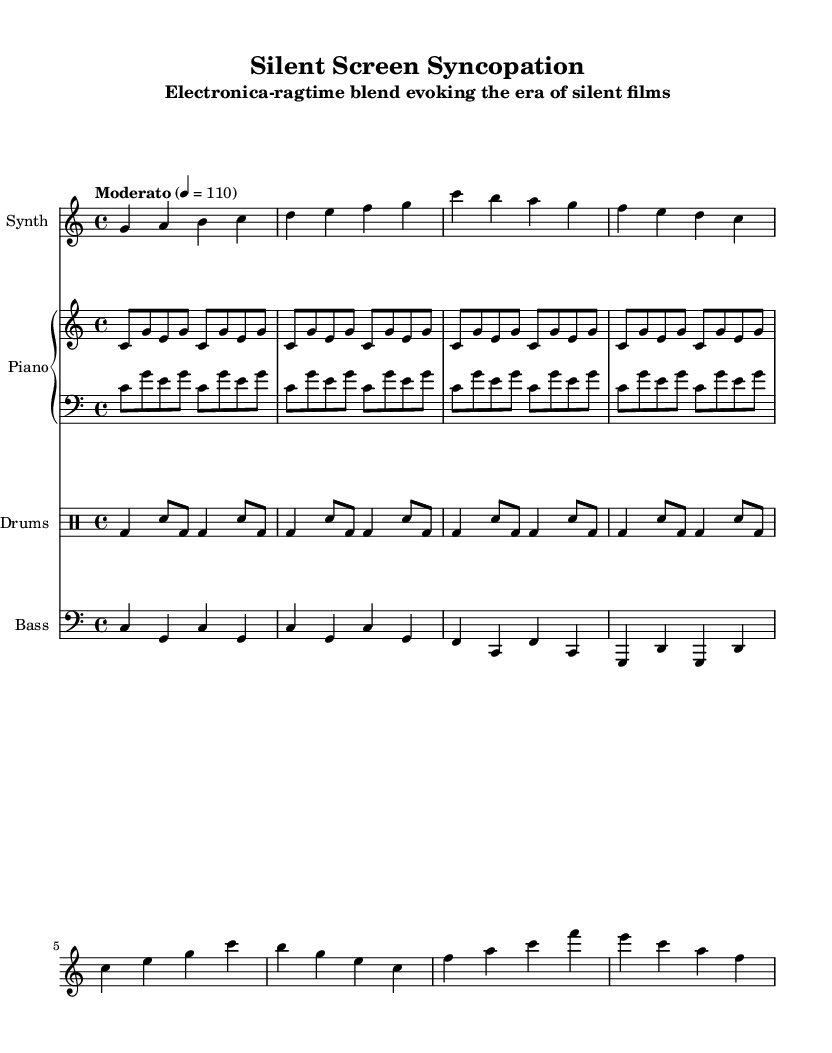What is the key signature of this music? The key signature is C major, which has no sharps or flats.
Answer: C major What is the time signature of this music? The time signature is indicated as 4/4, meaning there are four beats in each measure.
Answer: 4/4 What tempo marking is used in this piece? The tempo marking is "Moderato", indicating a moderate pace, and it specifies a speed of quarter note equals 110 beats per minute.
Answer: Moderato How many sections are identified in the music? There is an introduction followed by an A section, indicating at least two distinct parts of the music.
Answer: Two What is the rhythmic pattern of the drum machine? The drum machine employs a four-on-the-floor pattern combined with a syncopated snare emphasis, creating a distinctive rhythmic feel typical of electronica.
Answer: Four-on-the-floor What style of music does this piece predominantly evoke? The music blends elements of electronica with ragtime, suggesting an innovative fusion that evokes the era of silent films.
Answer: Electronica-ragtime What instrument is playing the bass line? The bass line is played by a bass synth, characterized by its alternating root and fifth patterns.
Answer: Bass synth 